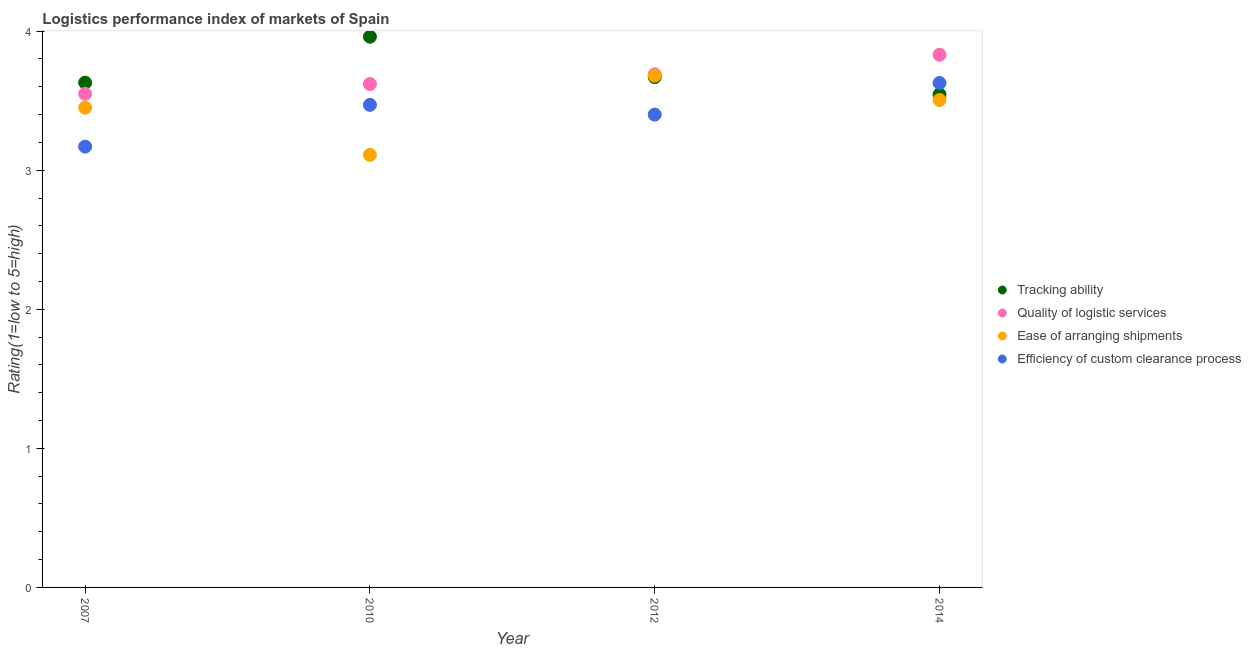How many different coloured dotlines are there?
Keep it short and to the point. 4. What is the lpi rating of quality of logistic services in 2010?
Provide a succinct answer. 3.62. Across all years, what is the maximum lpi rating of efficiency of custom clearance process?
Ensure brevity in your answer.  3.63. Across all years, what is the minimum lpi rating of efficiency of custom clearance process?
Give a very brief answer. 3.17. What is the total lpi rating of ease of arranging shipments in the graph?
Offer a terse response. 13.75. What is the difference between the lpi rating of ease of arranging shipments in 2007 and that in 2014?
Your answer should be compact. -0.06. What is the difference between the lpi rating of ease of arranging shipments in 2007 and the lpi rating of tracking ability in 2014?
Provide a short and direct response. -0.09. What is the average lpi rating of ease of arranging shipments per year?
Make the answer very short. 3.44. In the year 2010, what is the difference between the lpi rating of ease of arranging shipments and lpi rating of tracking ability?
Keep it short and to the point. -0.85. What is the ratio of the lpi rating of quality of logistic services in 2010 to that in 2012?
Provide a short and direct response. 0.98. Is the lpi rating of tracking ability in 2010 less than that in 2012?
Provide a short and direct response. No. Is the difference between the lpi rating of ease of arranging shipments in 2012 and 2014 greater than the difference between the lpi rating of quality of logistic services in 2012 and 2014?
Your answer should be very brief. Yes. What is the difference between the highest and the second highest lpi rating of efficiency of custom clearance process?
Ensure brevity in your answer.  0.16. What is the difference between the highest and the lowest lpi rating of efficiency of custom clearance process?
Your response must be concise. 0.46. Is it the case that in every year, the sum of the lpi rating of tracking ability and lpi rating of quality of logistic services is greater than the lpi rating of ease of arranging shipments?
Provide a succinct answer. Yes. Is the lpi rating of ease of arranging shipments strictly less than the lpi rating of tracking ability over the years?
Ensure brevity in your answer.  No. How many legend labels are there?
Your response must be concise. 4. What is the title of the graph?
Offer a very short reply. Logistics performance index of markets of Spain. Does "Source data assessment" appear as one of the legend labels in the graph?
Provide a short and direct response. No. What is the label or title of the Y-axis?
Provide a succinct answer. Rating(1=low to 5=high). What is the Rating(1=low to 5=high) in Tracking ability in 2007?
Ensure brevity in your answer.  3.63. What is the Rating(1=low to 5=high) in Quality of logistic services in 2007?
Your answer should be very brief. 3.55. What is the Rating(1=low to 5=high) in Ease of arranging shipments in 2007?
Give a very brief answer. 3.45. What is the Rating(1=low to 5=high) in Efficiency of custom clearance process in 2007?
Ensure brevity in your answer.  3.17. What is the Rating(1=low to 5=high) of Tracking ability in 2010?
Give a very brief answer. 3.96. What is the Rating(1=low to 5=high) in Quality of logistic services in 2010?
Offer a very short reply. 3.62. What is the Rating(1=low to 5=high) of Ease of arranging shipments in 2010?
Your response must be concise. 3.11. What is the Rating(1=low to 5=high) in Efficiency of custom clearance process in 2010?
Your response must be concise. 3.47. What is the Rating(1=low to 5=high) in Tracking ability in 2012?
Make the answer very short. 3.67. What is the Rating(1=low to 5=high) in Quality of logistic services in 2012?
Your response must be concise. 3.69. What is the Rating(1=low to 5=high) in Ease of arranging shipments in 2012?
Make the answer very short. 3.68. What is the Rating(1=low to 5=high) of Tracking ability in 2014?
Offer a terse response. 3.54. What is the Rating(1=low to 5=high) of Quality of logistic services in 2014?
Your answer should be very brief. 3.83. What is the Rating(1=low to 5=high) of Ease of arranging shipments in 2014?
Provide a short and direct response. 3.51. What is the Rating(1=low to 5=high) of Efficiency of custom clearance process in 2014?
Offer a very short reply. 3.63. Across all years, what is the maximum Rating(1=low to 5=high) in Tracking ability?
Give a very brief answer. 3.96. Across all years, what is the maximum Rating(1=low to 5=high) in Quality of logistic services?
Provide a short and direct response. 3.83. Across all years, what is the maximum Rating(1=low to 5=high) in Ease of arranging shipments?
Provide a succinct answer. 3.68. Across all years, what is the maximum Rating(1=low to 5=high) of Efficiency of custom clearance process?
Offer a very short reply. 3.63. Across all years, what is the minimum Rating(1=low to 5=high) in Tracking ability?
Give a very brief answer. 3.54. Across all years, what is the minimum Rating(1=low to 5=high) of Quality of logistic services?
Provide a short and direct response. 3.55. Across all years, what is the minimum Rating(1=low to 5=high) of Ease of arranging shipments?
Ensure brevity in your answer.  3.11. Across all years, what is the minimum Rating(1=low to 5=high) of Efficiency of custom clearance process?
Provide a short and direct response. 3.17. What is the total Rating(1=low to 5=high) of Tracking ability in the graph?
Keep it short and to the point. 14.8. What is the total Rating(1=low to 5=high) in Quality of logistic services in the graph?
Provide a short and direct response. 14.69. What is the total Rating(1=low to 5=high) of Ease of arranging shipments in the graph?
Keep it short and to the point. 13.75. What is the total Rating(1=low to 5=high) of Efficiency of custom clearance process in the graph?
Make the answer very short. 13.67. What is the difference between the Rating(1=low to 5=high) of Tracking ability in 2007 and that in 2010?
Ensure brevity in your answer.  -0.33. What is the difference between the Rating(1=low to 5=high) in Quality of logistic services in 2007 and that in 2010?
Provide a short and direct response. -0.07. What is the difference between the Rating(1=low to 5=high) in Ease of arranging shipments in 2007 and that in 2010?
Offer a terse response. 0.34. What is the difference between the Rating(1=low to 5=high) in Efficiency of custom clearance process in 2007 and that in 2010?
Ensure brevity in your answer.  -0.3. What is the difference between the Rating(1=low to 5=high) in Tracking ability in 2007 and that in 2012?
Give a very brief answer. -0.04. What is the difference between the Rating(1=low to 5=high) in Quality of logistic services in 2007 and that in 2012?
Make the answer very short. -0.14. What is the difference between the Rating(1=low to 5=high) in Ease of arranging shipments in 2007 and that in 2012?
Give a very brief answer. -0.23. What is the difference between the Rating(1=low to 5=high) of Efficiency of custom clearance process in 2007 and that in 2012?
Your response must be concise. -0.23. What is the difference between the Rating(1=low to 5=high) of Tracking ability in 2007 and that in 2014?
Your answer should be very brief. 0.09. What is the difference between the Rating(1=low to 5=high) of Quality of logistic services in 2007 and that in 2014?
Offer a very short reply. -0.28. What is the difference between the Rating(1=low to 5=high) in Ease of arranging shipments in 2007 and that in 2014?
Offer a very short reply. -0.06. What is the difference between the Rating(1=low to 5=high) of Efficiency of custom clearance process in 2007 and that in 2014?
Your response must be concise. -0.46. What is the difference between the Rating(1=low to 5=high) of Tracking ability in 2010 and that in 2012?
Offer a very short reply. 0.29. What is the difference between the Rating(1=low to 5=high) of Quality of logistic services in 2010 and that in 2012?
Give a very brief answer. -0.07. What is the difference between the Rating(1=low to 5=high) of Ease of arranging shipments in 2010 and that in 2012?
Ensure brevity in your answer.  -0.57. What is the difference between the Rating(1=low to 5=high) in Efficiency of custom clearance process in 2010 and that in 2012?
Your answer should be compact. 0.07. What is the difference between the Rating(1=low to 5=high) in Tracking ability in 2010 and that in 2014?
Offer a very short reply. 0.42. What is the difference between the Rating(1=low to 5=high) of Quality of logistic services in 2010 and that in 2014?
Ensure brevity in your answer.  -0.21. What is the difference between the Rating(1=low to 5=high) of Ease of arranging shipments in 2010 and that in 2014?
Your answer should be very brief. -0.4. What is the difference between the Rating(1=low to 5=high) of Efficiency of custom clearance process in 2010 and that in 2014?
Your answer should be compact. -0.16. What is the difference between the Rating(1=low to 5=high) of Tracking ability in 2012 and that in 2014?
Your answer should be very brief. 0.13. What is the difference between the Rating(1=low to 5=high) in Quality of logistic services in 2012 and that in 2014?
Your answer should be compact. -0.14. What is the difference between the Rating(1=low to 5=high) in Ease of arranging shipments in 2012 and that in 2014?
Your response must be concise. 0.17. What is the difference between the Rating(1=low to 5=high) in Efficiency of custom clearance process in 2012 and that in 2014?
Offer a terse response. -0.23. What is the difference between the Rating(1=low to 5=high) of Tracking ability in 2007 and the Rating(1=low to 5=high) of Quality of logistic services in 2010?
Your response must be concise. 0.01. What is the difference between the Rating(1=low to 5=high) in Tracking ability in 2007 and the Rating(1=low to 5=high) in Ease of arranging shipments in 2010?
Provide a short and direct response. 0.52. What is the difference between the Rating(1=low to 5=high) in Tracking ability in 2007 and the Rating(1=low to 5=high) in Efficiency of custom clearance process in 2010?
Your answer should be compact. 0.16. What is the difference between the Rating(1=low to 5=high) of Quality of logistic services in 2007 and the Rating(1=low to 5=high) of Ease of arranging shipments in 2010?
Your answer should be very brief. 0.44. What is the difference between the Rating(1=low to 5=high) of Quality of logistic services in 2007 and the Rating(1=low to 5=high) of Efficiency of custom clearance process in 2010?
Your response must be concise. 0.08. What is the difference between the Rating(1=low to 5=high) of Ease of arranging shipments in 2007 and the Rating(1=low to 5=high) of Efficiency of custom clearance process in 2010?
Provide a short and direct response. -0.02. What is the difference between the Rating(1=low to 5=high) of Tracking ability in 2007 and the Rating(1=low to 5=high) of Quality of logistic services in 2012?
Ensure brevity in your answer.  -0.06. What is the difference between the Rating(1=low to 5=high) in Tracking ability in 2007 and the Rating(1=low to 5=high) in Efficiency of custom clearance process in 2012?
Your answer should be very brief. 0.23. What is the difference between the Rating(1=low to 5=high) of Quality of logistic services in 2007 and the Rating(1=low to 5=high) of Ease of arranging shipments in 2012?
Offer a very short reply. -0.13. What is the difference between the Rating(1=low to 5=high) in Quality of logistic services in 2007 and the Rating(1=low to 5=high) in Efficiency of custom clearance process in 2012?
Offer a very short reply. 0.15. What is the difference between the Rating(1=low to 5=high) of Tracking ability in 2007 and the Rating(1=low to 5=high) of Quality of logistic services in 2014?
Your answer should be very brief. -0.2. What is the difference between the Rating(1=low to 5=high) in Tracking ability in 2007 and the Rating(1=low to 5=high) in Ease of arranging shipments in 2014?
Give a very brief answer. 0.12. What is the difference between the Rating(1=low to 5=high) of Tracking ability in 2007 and the Rating(1=low to 5=high) of Efficiency of custom clearance process in 2014?
Your response must be concise. 0. What is the difference between the Rating(1=low to 5=high) in Quality of logistic services in 2007 and the Rating(1=low to 5=high) in Ease of arranging shipments in 2014?
Provide a short and direct response. 0.04. What is the difference between the Rating(1=low to 5=high) of Quality of logistic services in 2007 and the Rating(1=low to 5=high) of Efficiency of custom clearance process in 2014?
Provide a short and direct response. -0.08. What is the difference between the Rating(1=low to 5=high) in Ease of arranging shipments in 2007 and the Rating(1=low to 5=high) in Efficiency of custom clearance process in 2014?
Your response must be concise. -0.18. What is the difference between the Rating(1=low to 5=high) of Tracking ability in 2010 and the Rating(1=low to 5=high) of Quality of logistic services in 2012?
Your response must be concise. 0.27. What is the difference between the Rating(1=low to 5=high) in Tracking ability in 2010 and the Rating(1=low to 5=high) in Ease of arranging shipments in 2012?
Ensure brevity in your answer.  0.28. What is the difference between the Rating(1=low to 5=high) in Tracking ability in 2010 and the Rating(1=low to 5=high) in Efficiency of custom clearance process in 2012?
Give a very brief answer. 0.56. What is the difference between the Rating(1=low to 5=high) of Quality of logistic services in 2010 and the Rating(1=low to 5=high) of Ease of arranging shipments in 2012?
Keep it short and to the point. -0.06. What is the difference between the Rating(1=low to 5=high) in Quality of logistic services in 2010 and the Rating(1=low to 5=high) in Efficiency of custom clearance process in 2012?
Provide a short and direct response. 0.22. What is the difference between the Rating(1=low to 5=high) of Ease of arranging shipments in 2010 and the Rating(1=low to 5=high) of Efficiency of custom clearance process in 2012?
Your answer should be very brief. -0.29. What is the difference between the Rating(1=low to 5=high) of Tracking ability in 2010 and the Rating(1=low to 5=high) of Quality of logistic services in 2014?
Ensure brevity in your answer.  0.13. What is the difference between the Rating(1=low to 5=high) of Tracking ability in 2010 and the Rating(1=low to 5=high) of Ease of arranging shipments in 2014?
Provide a succinct answer. 0.45. What is the difference between the Rating(1=low to 5=high) of Tracking ability in 2010 and the Rating(1=low to 5=high) of Efficiency of custom clearance process in 2014?
Your response must be concise. 0.33. What is the difference between the Rating(1=low to 5=high) in Quality of logistic services in 2010 and the Rating(1=low to 5=high) in Ease of arranging shipments in 2014?
Your answer should be very brief. 0.11. What is the difference between the Rating(1=low to 5=high) in Quality of logistic services in 2010 and the Rating(1=low to 5=high) in Efficiency of custom clearance process in 2014?
Ensure brevity in your answer.  -0.01. What is the difference between the Rating(1=low to 5=high) of Ease of arranging shipments in 2010 and the Rating(1=low to 5=high) of Efficiency of custom clearance process in 2014?
Your response must be concise. -0.52. What is the difference between the Rating(1=low to 5=high) in Tracking ability in 2012 and the Rating(1=low to 5=high) in Quality of logistic services in 2014?
Your response must be concise. -0.16. What is the difference between the Rating(1=low to 5=high) in Tracking ability in 2012 and the Rating(1=low to 5=high) in Ease of arranging shipments in 2014?
Your answer should be compact. 0.16. What is the difference between the Rating(1=low to 5=high) in Tracking ability in 2012 and the Rating(1=low to 5=high) in Efficiency of custom clearance process in 2014?
Your answer should be very brief. 0.04. What is the difference between the Rating(1=low to 5=high) in Quality of logistic services in 2012 and the Rating(1=low to 5=high) in Ease of arranging shipments in 2014?
Your answer should be compact. 0.18. What is the difference between the Rating(1=low to 5=high) in Quality of logistic services in 2012 and the Rating(1=low to 5=high) in Efficiency of custom clearance process in 2014?
Keep it short and to the point. 0.06. What is the difference between the Rating(1=low to 5=high) of Ease of arranging shipments in 2012 and the Rating(1=low to 5=high) of Efficiency of custom clearance process in 2014?
Keep it short and to the point. 0.05. What is the average Rating(1=low to 5=high) of Tracking ability per year?
Give a very brief answer. 3.7. What is the average Rating(1=low to 5=high) of Quality of logistic services per year?
Offer a very short reply. 3.67. What is the average Rating(1=low to 5=high) in Ease of arranging shipments per year?
Make the answer very short. 3.44. What is the average Rating(1=low to 5=high) of Efficiency of custom clearance process per year?
Your answer should be compact. 3.42. In the year 2007, what is the difference between the Rating(1=low to 5=high) of Tracking ability and Rating(1=low to 5=high) of Quality of logistic services?
Offer a terse response. 0.08. In the year 2007, what is the difference between the Rating(1=low to 5=high) of Tracking ability and Rating(1=low to 5=high) of Ease of arranging shipments?
Offer a terse response. 0.18. In the year 2007, what is the difference between the Rating(1=low to 5=high) in Tracking ability and Rating(1=low to 5=high) in Efficiency of custom clearance process?
Your answer should be very brief. 0.46. In the year 2007, what is the difference between the Rating(1=low to 5=high) of Quality of logistic services and Rating(1=low to 5=high) of Efficiency of custom clearance process?
Provide a short and direct response. 0.38. In the year 2007, what is the difference between the Rating(1=low to 5=high) of Ease of arranging shipments and Rating(1=low to 5=high) of Efficiency of custom clearance process?
Your answer should be compact. 0.28. In the year 2010, what is the difference between the Rating(1=low to 5=high) in Tracking ability and Rating(1=low to 5=high) in Quality of logistic services?
Your answer should be very brief. 0.34. In the year 2010, what is the difference between the Rating(1=low to 5=high) of Tracking ability and Rating(1=low to 5=high) of Efficiency of custom clearance process?
Ensure brevity in your answer.  0.49. In the year 2010, what is the difference between the Rating(1=low to 5=high) in Quality of logistic services and Rating(1=low to 5=high) in Ease of arranging shipments?
Provide a succinct answer. 0.51. In the year 2010, what is the difference between the Rating(1=low to 5=high) of Quality of logistic services and Rating(1=low to 5=high) of Efficiency of custom clearance process?
Provide a short and direct response. 0.15. In the year 2010, what is the difference between the Rating(1=low to 5=high) of Ease of arranging shipments and Rating(1=low to 5=high) of Efficiency of custom clearance process?
Ensure brevity in your answer.  -0.36. In the year 2012, what is the difference between the Rating(1=low to 5=high) of Tracking ability and Rating(1=low to 5=high) of Quality of logistic services?
Your answer should be very brief. -0.02. In the year 2012, what is the difference between the Rating(1=low to 5=high) in Tracking ability and Rating(1=low to 5=high) in Ease of arranging shipments?
Provide a succinct answer. -0.01. In the year 2012, what is the difference between the Rating(1=low to 5=high) of Tracking ability and Rating(1=low to 5=high) of Efficiency of custom clearance process?
Make the answer very short. 0.27. In the year 2012, what is the difference between the Rating(1=low to 5=high) in Quality of logistic services and Rating(1=low to 5=high) in Ease of arranging shipments?
Your answer should be very brief. 0.01. In the year 2012, what is the difference between the Rating(1=low to 5=high) in Quality of logistic services and Rating(1=low to 5=high) in Efficiency of custom clearance process?
Provide a succinct answer. 0.29. In the year 2012, what is the difference between the Rating(1=low to 5=high) in Ease of arranging shipments and Rating(1=low to 5=high) in Efficiency of custom clearance process?
Provide a short and direct response. 0.28. In the year 2014, what is the difference between the Rating(1=low to 5=high) of Tracking ability and Rating(1=low to 5=high) of Quality of logistic services?
Offer a terse response. -0.29. In the year 2014, what is the difference between the Rating(1=low to 5=high) in Tracking ability and Rating(1=low to 5=high) in Ease of arranging shipments?
Provide a succinct answer. 0.04. In the year 2014, what is the difference between the Rating(1=low to 5=high) in Tracking ability and Rating(1=low to 5=high) in Efficiency of custom clearance process?
Offer a terse response. -0.08. In the year 2014, what is the difference between the Rating(1=low to 5=high) of Quality of logistic services and Rating(1=low to 5=high) of Ease of arranging shipments?
Provide a short and direct response. 0.33. In the year 2014, what is the difference between the Rating(1=low to 5=high) of Quality of logistic services and Rating(1=low to 5=high) of Efficiency of custom clearance process?
Make the answer very short. 0.2. In the year 2014, what is the difference between the Rating(1=low to 5=high) of Ease of arranging shipments and Rating(1=low to 5=high) of Efficiency of custom clearance process?
Offer a terse response. -0.12. What is the ratio of the Rating(1=low to 5=high) of Tracking ability in 2007 to that in 2010?
Your answer should be compact. 0.92. What is the ratio of the Rating(1=low to 5=high) in Quality of logistic services in 2007 to that in 2010?
Ensure brevity in your answer.  0.98. What is the ratio of the Rating(1=low to 5=high) in Ease of arranging shipments in 2007 to that in 2010?
Offer a very short reply. 1.11. What is the ratio of the Rating(1=low to 5=high) of Efficiency of custom clearance process in 2007 to that in 2010?
Keep it short and to the point. 0.91. What is the ratio of the Rating(1=low to 5=high) in Quality of logistic services in 2007 to that in 2012?
Offer a very short reply. 0.96. What is the ratio of the Rating(1=low to 5=high) of Efficiency of custom clearance process in 2007 to that in 2012?
Your answer should be compact. 0.93. What is the ratio of the Rating(1=low to 5=high) of Tracking ability in 2007 to that in 2014?
Offer a very short reply. 1.02. What is the ratio of the Rating(1=low to 5=high) of Quality of logistic services in 2007 to that in 2014?
Your response must be concise. 0.93. What is the ratio of the Rating(1=low to 5=high) of Ease of arranging shipments in 2007 to that in 2014?
Keep it short and to the point. 0.98. What is the ratio of the Rating(1=low to 5=high) of Efficiency of custom clearance process in 2007 to that in 2014?
Your answer should be very brief. 0.87. What is the ratio of the Rating(1=low to 5=high) in Tracking ability in 2010 to that in 2012?
Provide a short and direct response. 1.08. What is the ratio of the Rating(1=low to 5=high) of Quality of logistic services in 2010 to that in 2012?
Give a very brief answer. 0.98. What is the ratio of the Rating(1=low to 5=high) in Ease of arranging shipments in 2010 to that in 2012?
Provide a short and direct response. 0.85. What is the ratio of the Rating(1=low to 5=high) of Efficiency of custom clearance process in 2010 to that in 2012?
Provide a short and direct response. 1.02. What is the ratio of the Rating(1=low to 5=high) of Tracking ability in 2010 to that in 2014?
Keep it short and to the point. 1.12. What is the ratio of the Rating(1=low to 5=high) of Quality of logistic services in 2010 to that in 2014?
Your answer should be compact. 0.95. What is the ratio of the Rating(1=low to 5=high) in Ease of arranging shipments in 2010 to that in 2014?
Keep it short and to the point. 0.89. What is the ratio of the Rating(1=low to 5=high) in Efficiency of custom clearance process in 2010 to that in 2014?
Your response must be concise. 0.96. What is the ratio of the Rating(1=low to 5=high) in Tracking ability in 2012 to that in 2014?
Your answer should be compact. 1.04. What is the ratio of the Rating(1=low to 5=high) in Quality of logistic services in 2012 to that in 2014?
Provide a short and direct response. 0.96. What is the ratio of the Rating(1=low to 5=high) of Ease of arranging shipments in 2012 to that in 2014?
Provide a short and direct response. 1.05. What is the ratio of the Rating(1=low to 5=high) in Efficiency of custom clearance process in 2012 to that in 2014?
Ensure brevity in your answer.  0.94. What is the difference between the highest and the second highest Rating(1=low to 5=high) in Tracking ability?
Provide a succinct answer. 0.29. What is the difference between the highest and the second highest Rating(1=low to 5=high) of Quality of logistic services?
Make the answer very short. 0.14. What is the difference between the highest and the second highest Rating(1=low to 5=high) in Ease of arranging shipments?
Keep it short and to the point. 0.17. What is the difference between the highest and the second highest Rating(1=low to 5=high) in Efficiency of custom clearance process?
Offer a terse response. 0.16. What is the difference between the highest and the lowest Rating(1=low to 5=high) of Tracking ability?
Provide a short and direct response. 0.42. What is the difference between the highest and the lowest Rating(1=low to 5=high) in Quality of logistic services?
Provide a short and direct response. 0.28. What is the difference between the highest and the lowest Rating(1=low to 5=high) in Ease of arranging shipments?
Offer a terse response. 0.57. What is the difference between the highest and the lowest Rating(1=low to 5=high) in Efficiency of custom clearance process?
Provide a succinct answer. 0.46. 